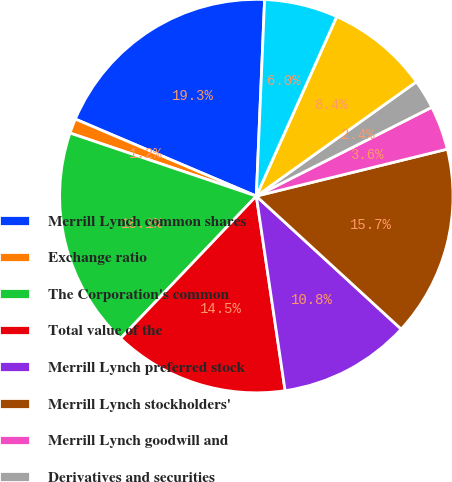Convert chart to OTSL. <chart><loc_0><loc_0><loc_500><loc_500><pie_chart><fcel>Merrill Lynch common shares<fcel>Exchange ratio<fcel>The Corporation's common<fcel>Total value of the<fcel>Merrill Lynch preferred stock<fcel>Merrill Lynch stockholders'<fcel>Merrill Lynch goodwill and<fcel>Derivatives and securities<fcel>Loans<fcel>Intangible assets (2)<nl><fcel>19.27%<fcel>1.21%<fcel>18.07%<fcel>14.46%<fcel>10.84%<fcel>15.66%<fcel>3.62%<fcel>2.41%<fcel>8.43%<fcel>6.03%<nl></chart> 